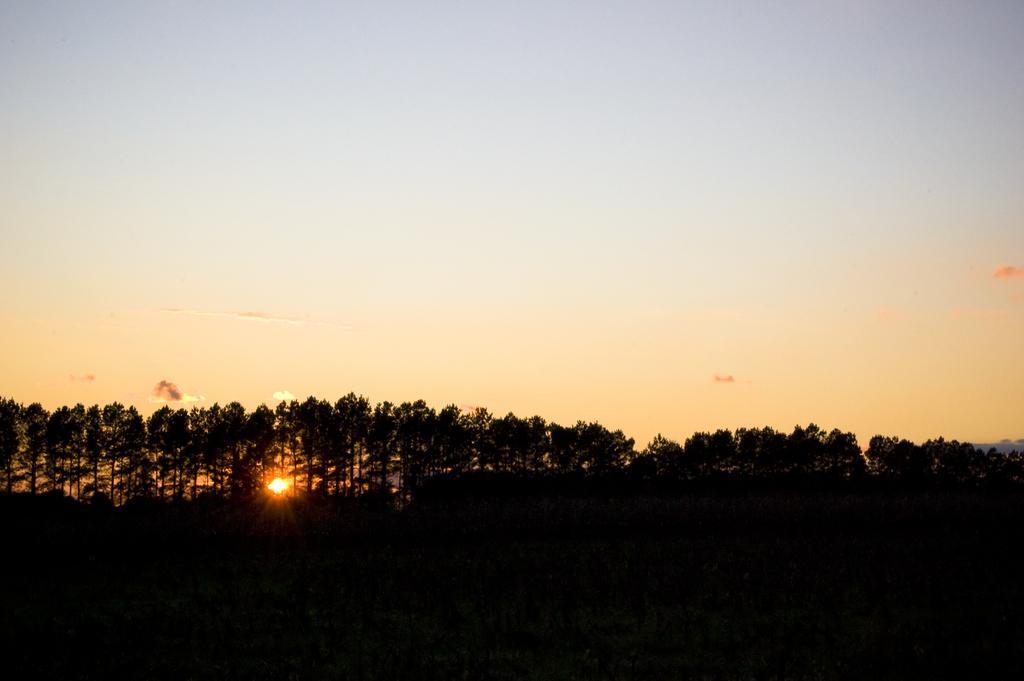Could you give a brief overview of what you see in this image? In this picture I can see there are few trees and the sky is clear and sunny. 